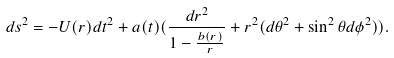<formula> <loc_0><loc_0><loc_500><loc_500>d s ^ { 2 } = - U ( r ) d t ^ { 2 } + a ( t ) ( \frac { d r ^ { 2 } } { 1 - \frac { b ( r ) } { r } } + r ^ { 2 } ( d \theta ^ { 2 } + \sin ^ { 2 } \theta d \phi ^ { 2 } ) ) .</formula> 